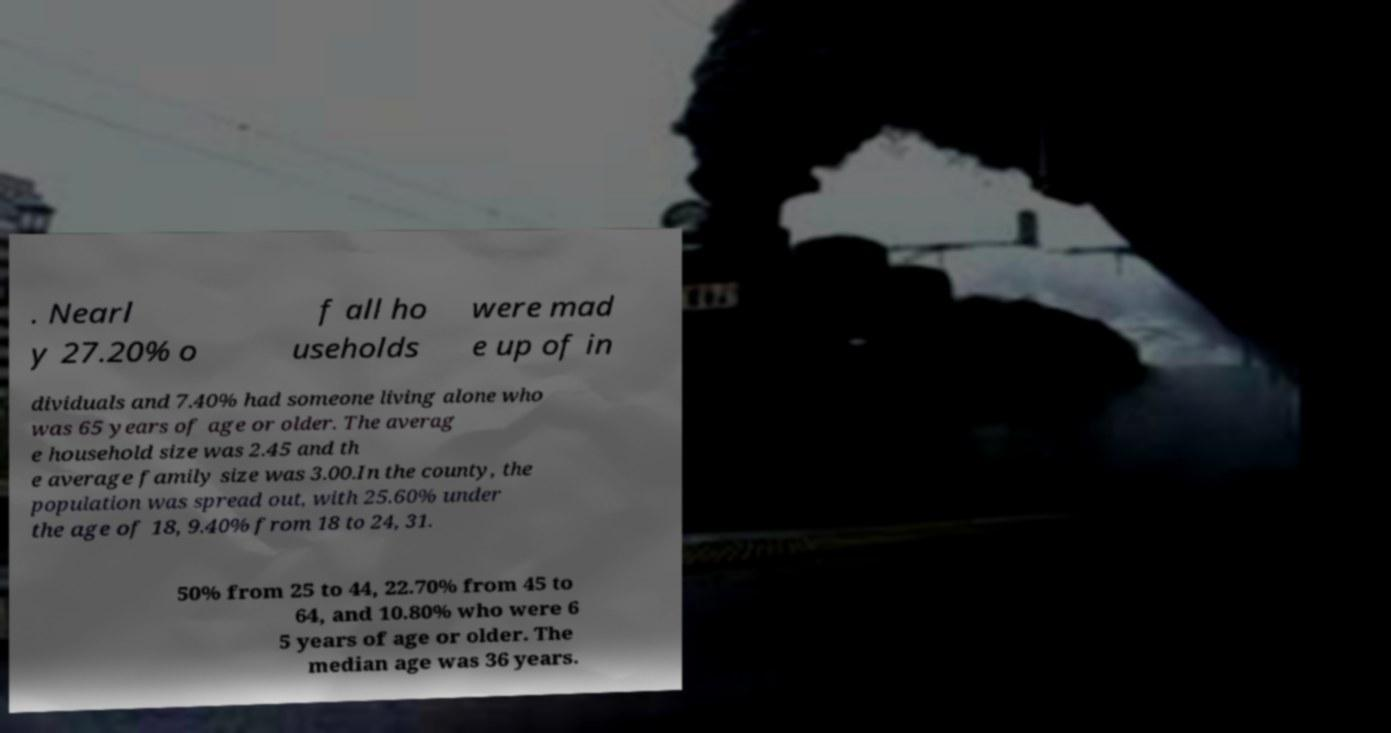What messages or text are displayed in this image? I need them in a readable, typed format. . Nearl y 27.20% o f all ho useholds were mad e up of in dividuals and 7.40% had someone living alone who was 65 years of age or older. The averag e household size was 2.45 and th e average family size was 3.00.In the county, the population was spread out, with 25.60% under the age of 18, 9.40% from 18 to 24, 31. 50% from 25 to 44, 22.70% from 45 to 64, and 10.80% who were 6 5 years of age or older. The median age was 36 years. 